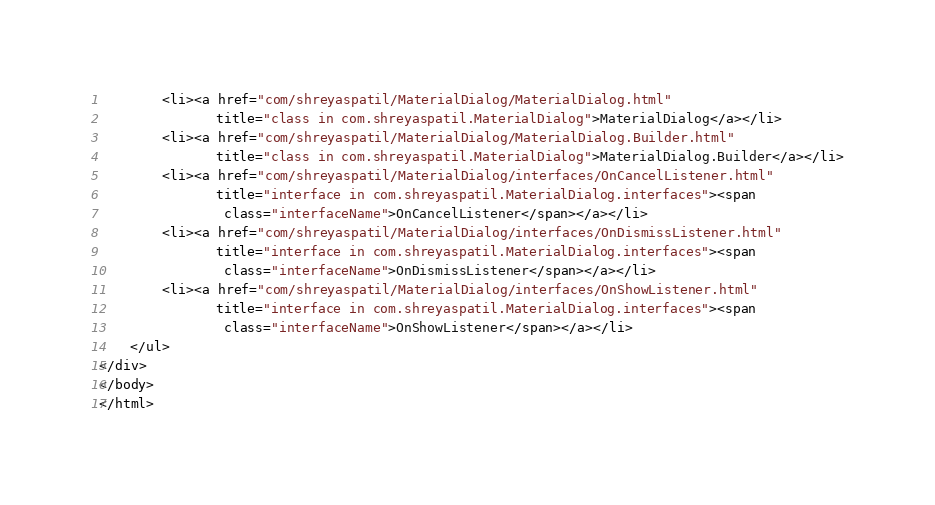<code> <loc_0><loc_0><loc_500><loc_500><_HTML_>        <li><a href="com/shreyaspatil/MaterialDialog/MaterialDialog.html"
               title="class in com.shreyaspatil.MaterialDialog">MaterialDialog</a></li>
        <li><a href="com/shreyaspatil/MaterialDialog/MaterialDialog.Builder.html"
               title="class in com.shreyaspatil.MaterialDialog">MaterialDialog.Builder</a></li>
        <li><a href="com/shreyaspatil/MaterialDialog/interfaces/OnCancelListener.html"
               title="interface in com.shreyaspatil.MaterialDialog.interfaces"><span
                class="interfaceName">OnCancelListener</span></a></li>
        <li><a href="com/shreyaspatil/MaterialDialog/interfaces/OnDismissListener.html"
               title="interface in com.shreyaspatil.MaterialDialog.interfaces"><span
                class="interfaceName">OnDismissListener</span></a></li>
        <li><a href="com/shreyaspatil/MaterialDialog/interfaces/OnShowListener.html"
               title="interface in com.shreyaspatil.MaterialDialog.interfaces"><span
                class="interfaceName">OnShowListener</span></a></li>
    </ul>
</div>
</body>
</html>
</code> 